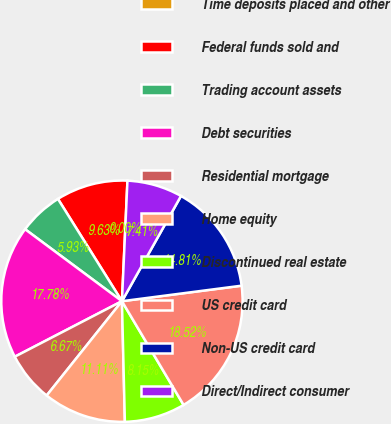<chart> <loc_0><loc_0><loc_500><loc_500><pie_chart><fcel>Time deposits placed and other<fcel>Federal funds sold and<fcel>Trading account assets<fcel>Debt securities<fcel>Residential mortgage<fcel>Home equity<fcel>Discontinued real estate<fcel>US credit card<fcel>Non-US credit card<fcel>Direct/Indirect consumer<nl><fcel>0.0%<fcel>9.63%<fcel>5.93%<fcel>17.78%<fcel>6.67%<fcel>11.11%<fcel>8.15%<fcel>18.52%<fcel>14.81%<fcel>7.41%<nl></chart> 